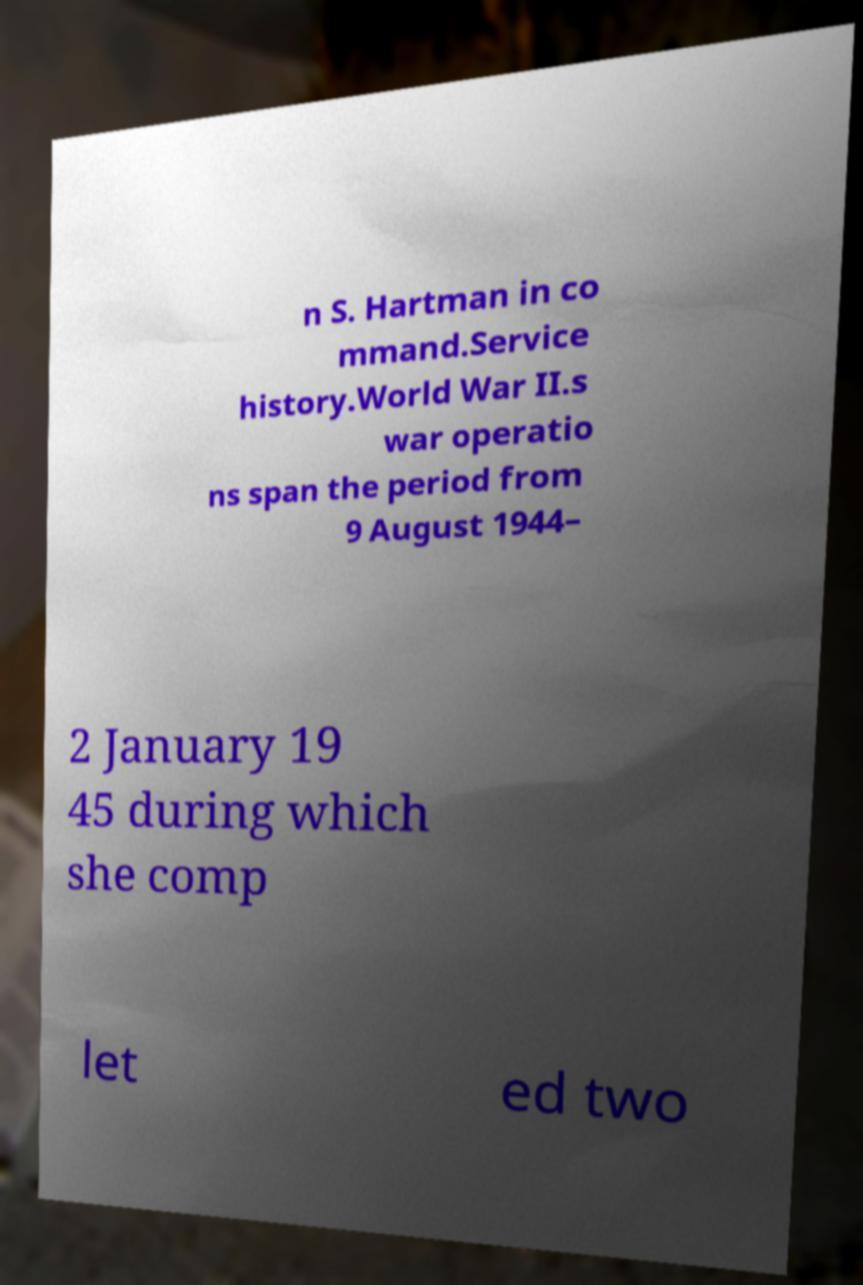Could you extract and type out the text from this image? n S. Hartman in co mmand.Service history.World War II.s war operatio ns span the period from 9 August 1944– 2 January 19 45 during which she comp let ed two 